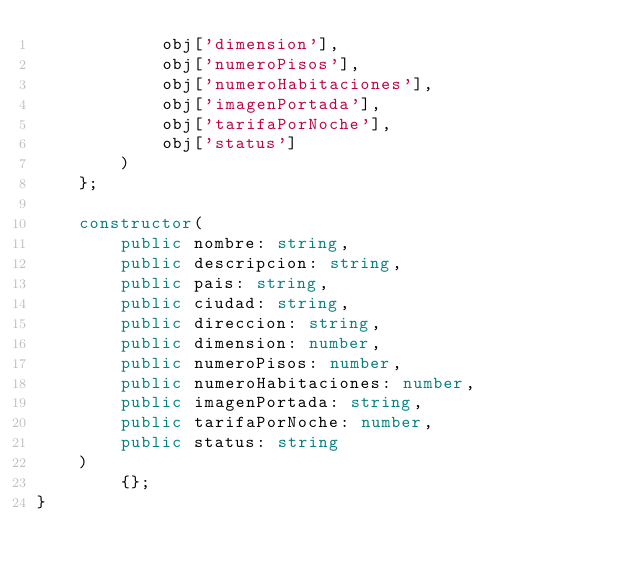<code> <loc_0><loc_0><loc_500><loc_500><_TypeScript_>            obj['dimension'],
            obj['numeroPisos'],
            obj['numeroHabitaciones'],
            obj['imagenPortada'],
            obj['tarifaPorNoche'],
            obj['status'] 
        )
    };

    constructor( 
        public nombre: string,
        public descripcion: string,
        public pais: string,
        public ciudad: string,
        public direccion: string,
        public dimension: number,
        public numeroPisos: number,
        public numeroHabitaciones: number,
        public imagenPortada: string,
        public tarifaPorNoche: number,
        public status: string
    )
        {};
}</code> 